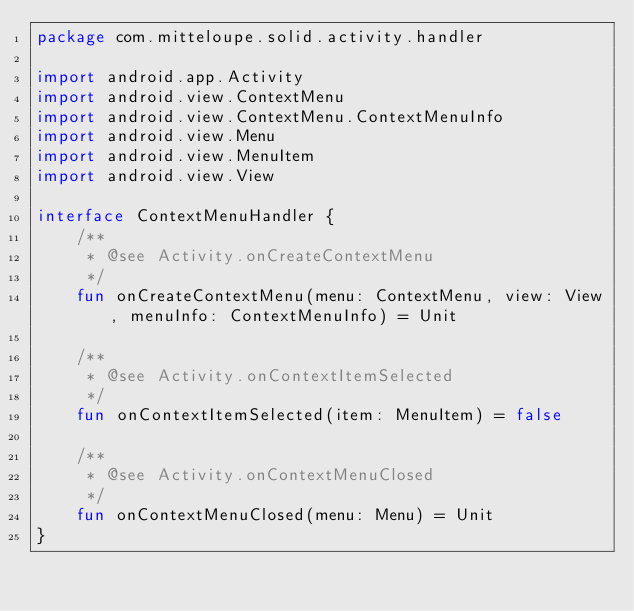Convert code to text. <code><loc_0><loc_0><loc_500><loc_500><_Kotlin_>package com.mitteloupe.solid.activity.handler

import android.app.Activity
import android.view.ContextMenu
import android.view.ContextMenu.ContextMenuInfo
import android.view.Menu
import android.view.MenuItem
import android.view.View

interface ContextMenuHandler {
    /**
     * @see Activity.onCreateContextMenu
     */
    fun onCreateContextMenu(menu: ContextMenu, view: View, menuInfo: ContextMenuInfo) = Unit

    /**
     * @see Activity.onContextItemSelected
     */
    fun onContextItemSelected(item: MenuItem) = false

    /**
     * @see Activity.onContextMenuClosed
     */
    fun onContextMenuClosed(menu: Menu) = Unit
}
</code> 